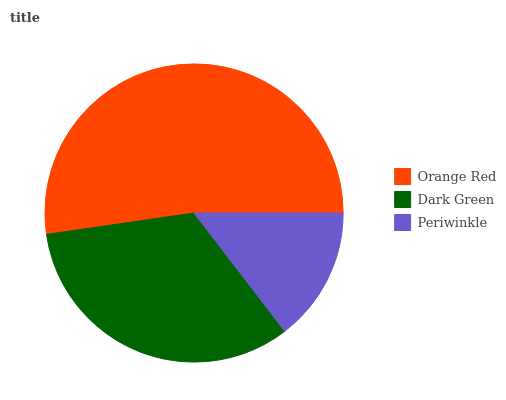Is Periwinkle the minimum?
Answer yes or no. Yes. Is Orange Red the maximum?
Answer yes or no. Yes. Is Dark Green the minimum?
Answer yes or no. No. Is Dark Green the maximum?
Answer yes or no. No. Is Orange Red greater than Dark Green?
Answer yes or no. Yes. Is Dark Green less than Orange Red?
Answer yes or no. Yes. Is Dark Green greater than Orange Red?
Answer yes or no. No. Is Orange Red less than Dark Green?
Answer yes or no. No. Is Dark Green the high median?
Answer yes or no. Yes. Is Dark Green the low median?
Answer yes or no. Yes. Is Periwinkle the high median?
Answer yes or no. No. Is Orange Red the low median?
Answer yes or no. No. 